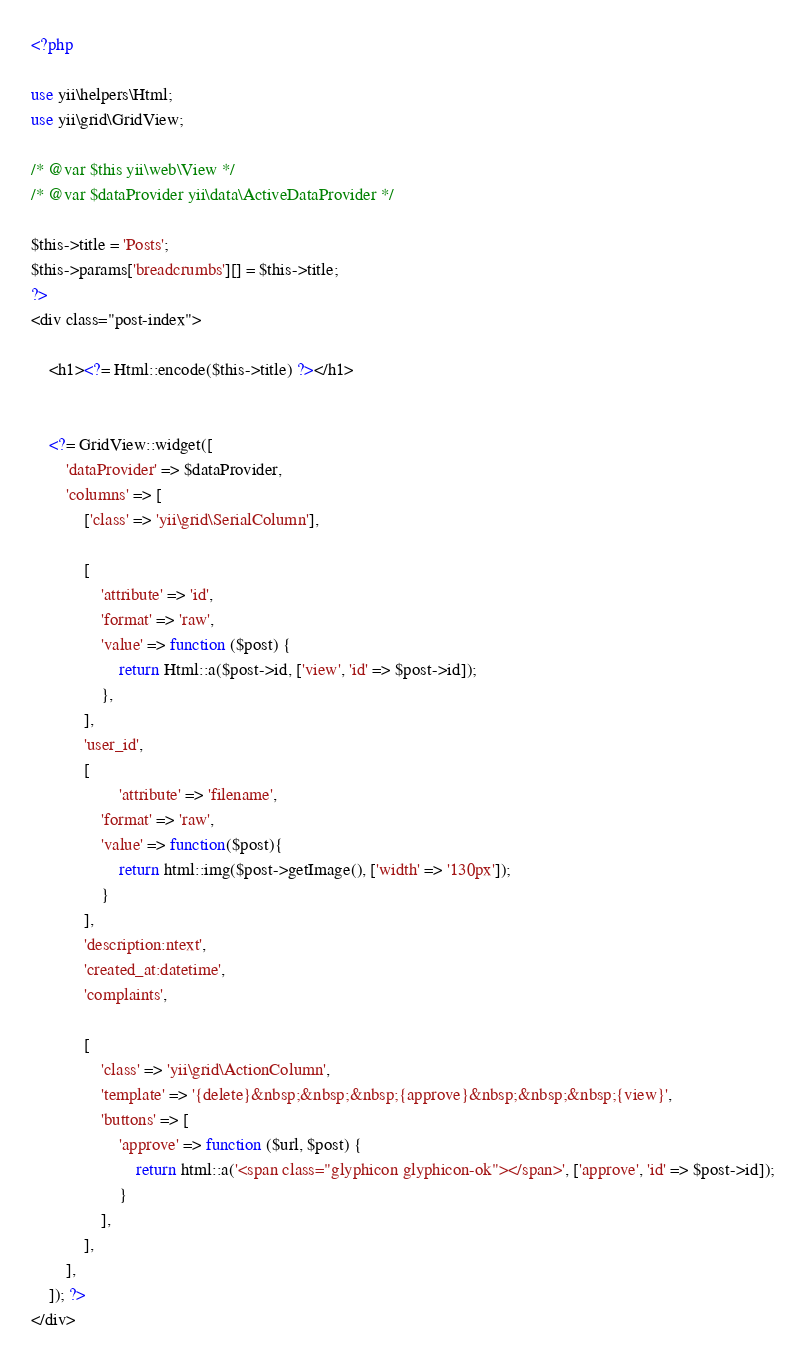Convert code to text. <code><loc_0><loc_0><loc_500><loc_500><_PHP_><?php

use yii\helpers\Html;
use yii\grid\GridView;

/* @var $this yii\web\View */
/* @var $dataProvider yii\data\ActiveDataProvider */

$this->title = 'Posts';
$this->params['breadcrumbs'][] = $this->title;
?>
<div class="post-index">

    <h1><?= Html::encode($this->title) ?></h1>


    <?= GridView::widget([
        'dataProvider' => $dataProvider,
        'columns' => [
            ['class' => 'yii\grid\SerialColumn'],

            [
                'attribute' => 'id',
                'format' => 'raw',
                'value' => function ($post) {
                    return Html::a($post->id, ['view', 'id' => $post->id]);
                },
            ],
            'user_id',
            [
                    'attribute' => 'filename',
                'format' => 'raw',
                'value' => function($post){
                    return html::img($post->getImage(), ['width' => '130px']);
                }
            ],
            'description:ntext',
            'created_at:datetime',
            'complaints',

            [
                'class' => 'yii\grid\ActionColumn',
                'template' => '{delete}&nbsp;&nbsp;&nbsp;{approve}&nbsp;&nbsp;&nbsp;{view}',
                'buttons' => [
                    'approve' => function ($url, $post) {
                        return html::a('<span class="glyphicon glyphicon-ok"></span>', ['approve', 'id' => $post->id]);
                    }
                ],
            ],
        ],
    ]); ?>
</div>
</code> 